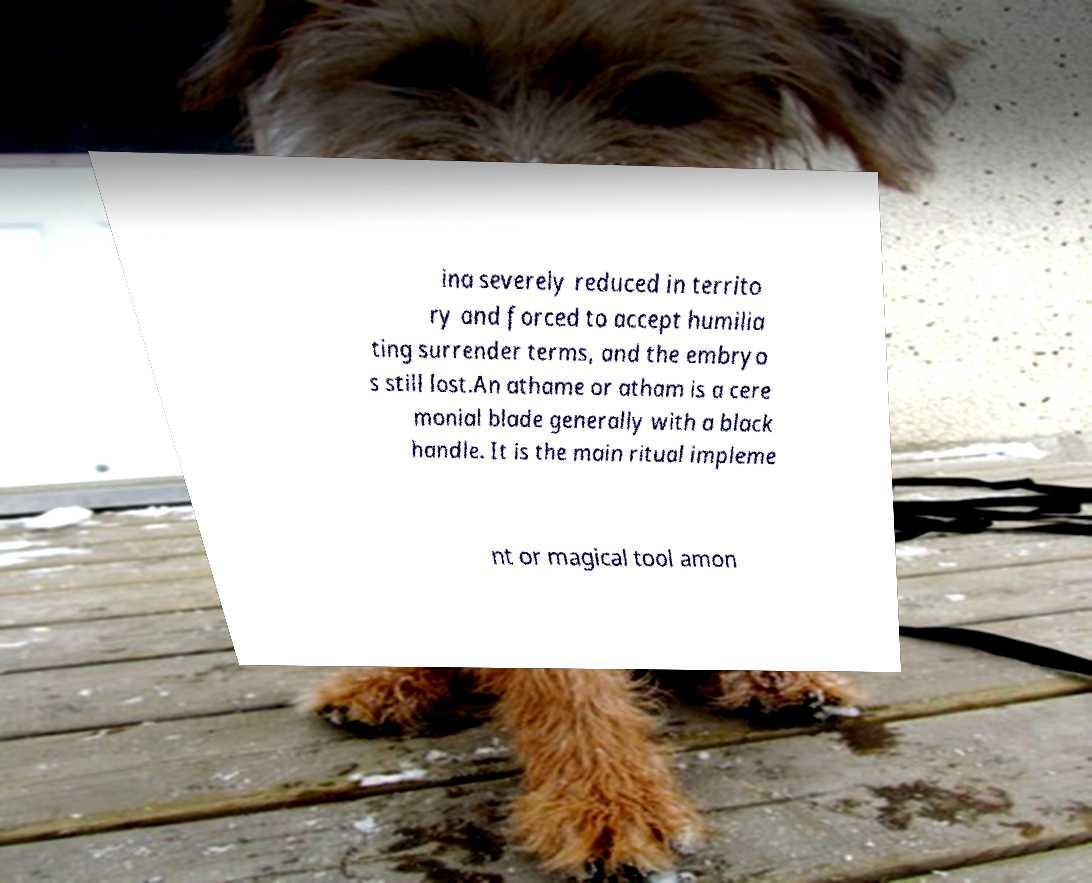Can you accurately transcribe the text from the provided image for me? ina severely reduced in territo ry and forced to accept humilia ting surrender terms, and the embryo s still lost.An athame or atham is a cere monial blade generally with a black handle. It is the main ritual impleme nt or magical tool amon 